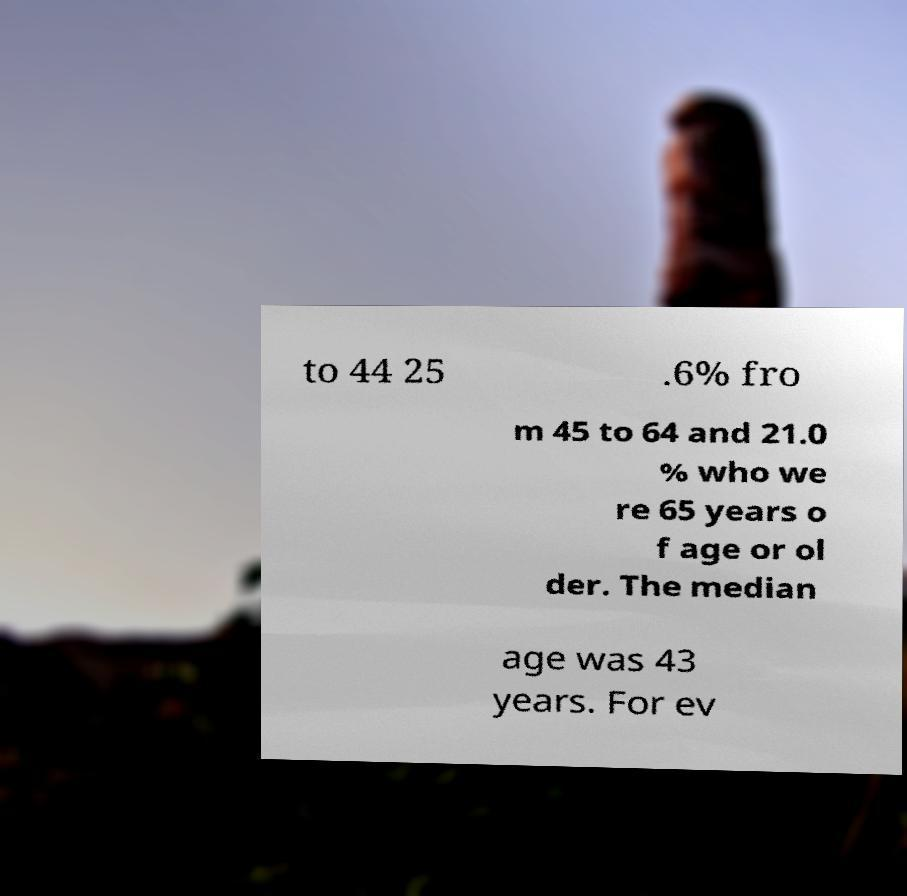I need the written content from this picture converted into text. Can you do that? to 44 25 .6% fro m 45 to 64 and 21.0 % who we re 65 years o f age or ol der. The median age was 43 years. For ev 